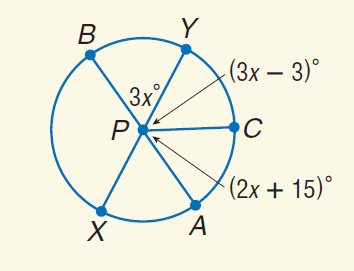Answer the mathemtical geometry problem and directly provide the correct option letter.
Question: Find m \widehat B C A.
Choices: A: 30 B: 45 C: 55 D: 180 D 